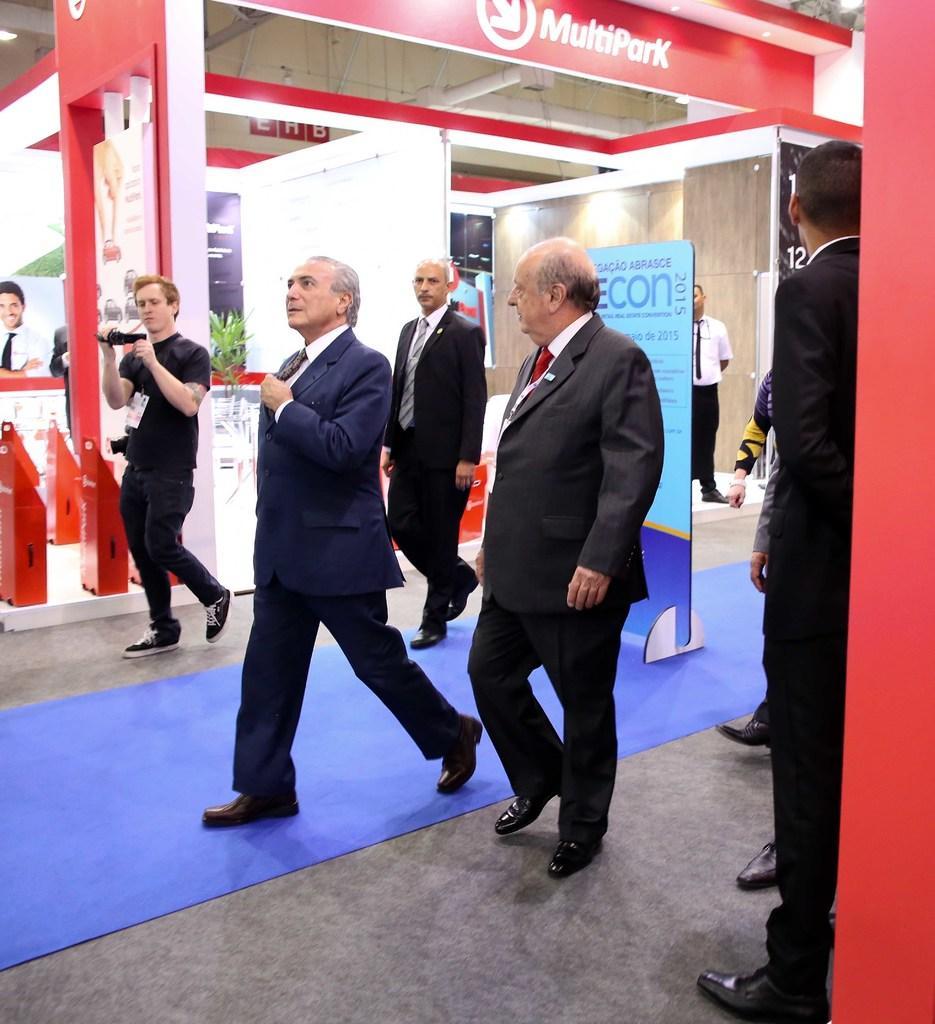Describe this image in one or two sentences. On the right side there is a person standing. Also there are few people walking. One person is holding a camera. And there is a board with something written on that. In the back there are boards with something written on that. 